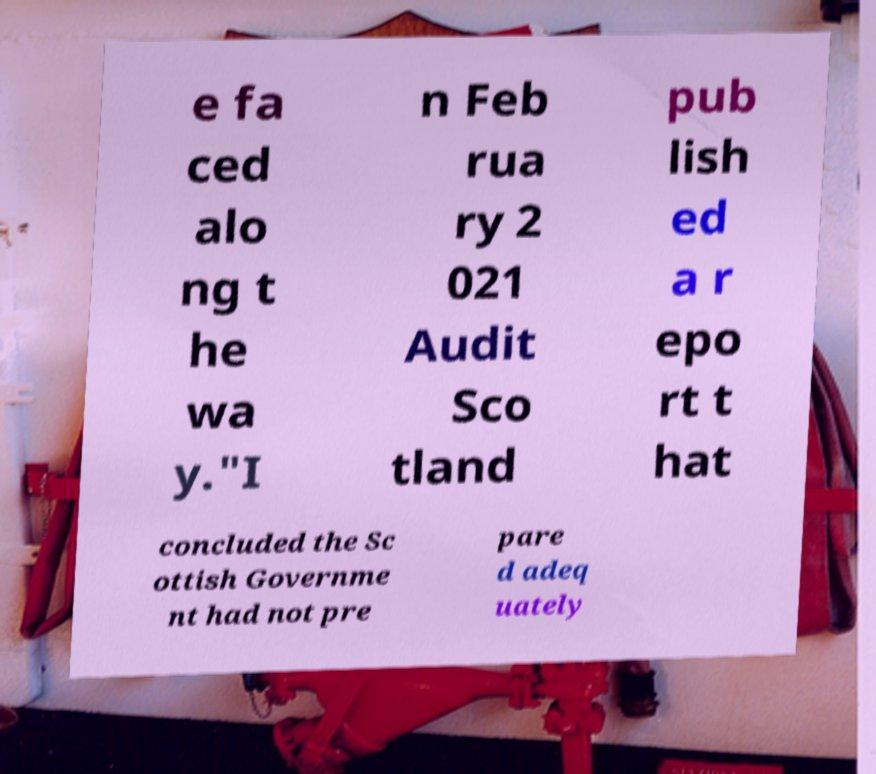Can you read and provide the text displayed in the image?This photo seems to have some interesting text. Can you extract and type it out for me? e fa ced alo ng t he wa y."I n Feb rua ry 2 021 Audit Sco tland pub lish ed a r epo rt t hat concluded the Sc ottish Governme nt had not pre pare d adeq uately 